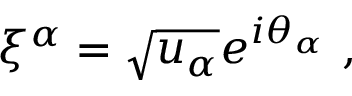<formula> <loc_0><loc_0><loc_500><loc_500>\xi ^ { \alpha } = \sqrt { u _ { \alpha } } e ^ { i \theta _ { \alpha } } \ ,</formula> 